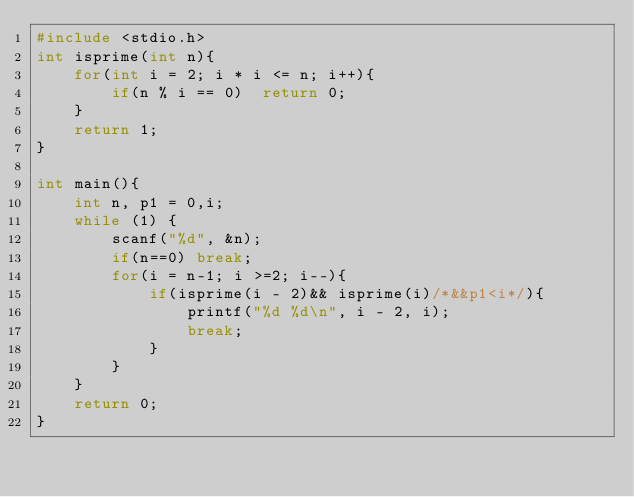<code> <loc_0><loc_0><loc_500><loc_500><_C_>#include <stdio.h>
int isprime(int n){
    for(int i = 2; i * i <= n; i++){
        if(n % i == 0)  return 0;
    }
    return 1;
}

int main(){
    int n, p1 = 0,i;
    while (1) {
        scanf("%d", &n);
        if(n==0) break;
        for(i = n-1; i >=2; i--){
            if(isprime(i - 2)&& isprime(i)/*&&p1<i*/){
                printf("%d %d\n", i - 2, i);
                break;
            }
        }
    }
    return 0;
}</code> 